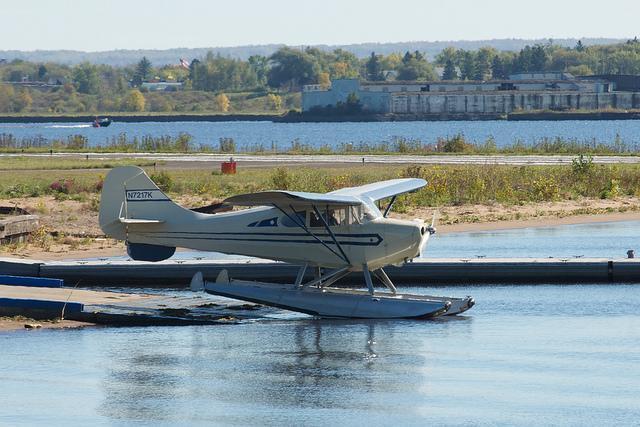What class of aircraft is seen here?
Indicate the correct response by choosing from the four available options to answer the question.
Options: Helicopter, amphibious, cargo plane, fighter jet. Amphibious. 